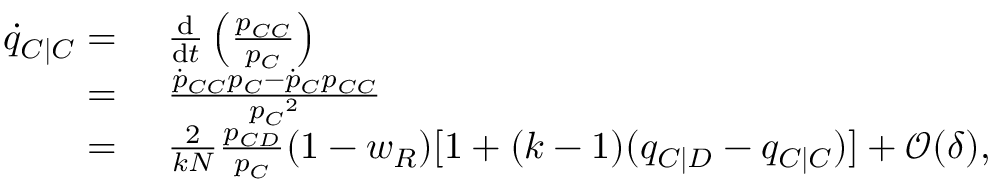<formula> <loc_0><loc_0><loc_500><loc_500>\begin{array} { r l } { \dot { q } _ { C | C } = } & { \frac { d } { d t } \left ( \frac { p _ { C C } } { p _ { C } } \right ) } \\ { = } & { \frac { \dot { p } _ { C C } p _ { C } - \dot { p } _ { C } p _ { C C } } { { p _ { C } } ^ { 2 } } } \\ { = } & { \frac { 2 } { k N } \frac { p _ { C D } } { p _ { C } } ( 1 - w _ { R } ) [ 1 + ( k - 1 ) ( q _ { C | D } - q _ { C | C } ) ] + \mathcal { O } ( \delta ) , } \end{array}</formula> 